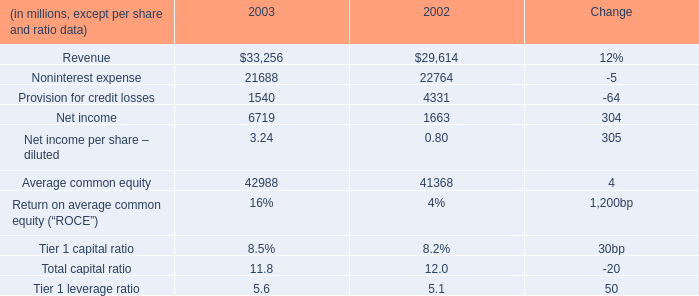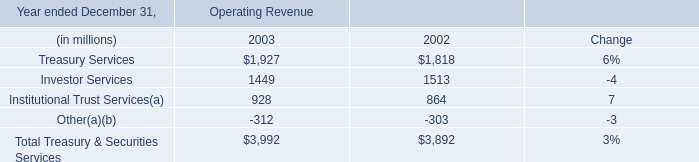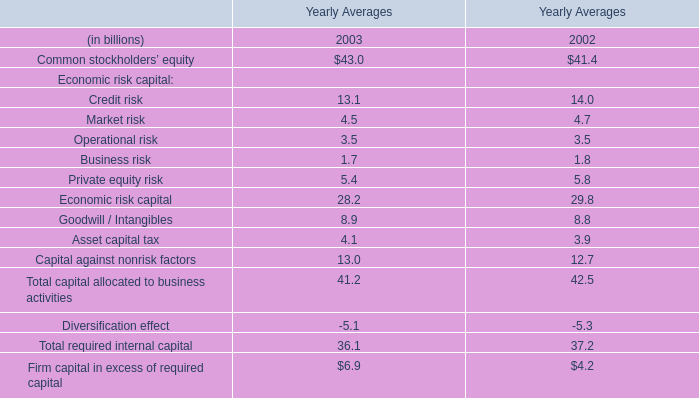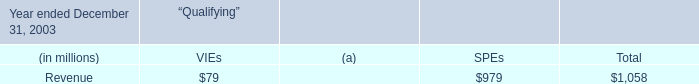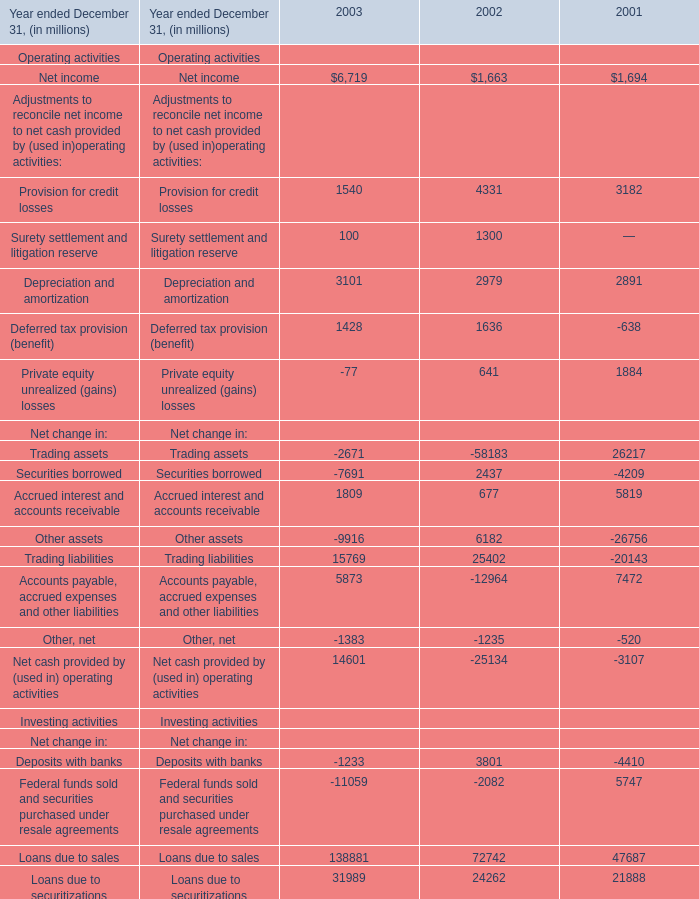In which year is Net income greater than 6000? 
Answer: 2003. 